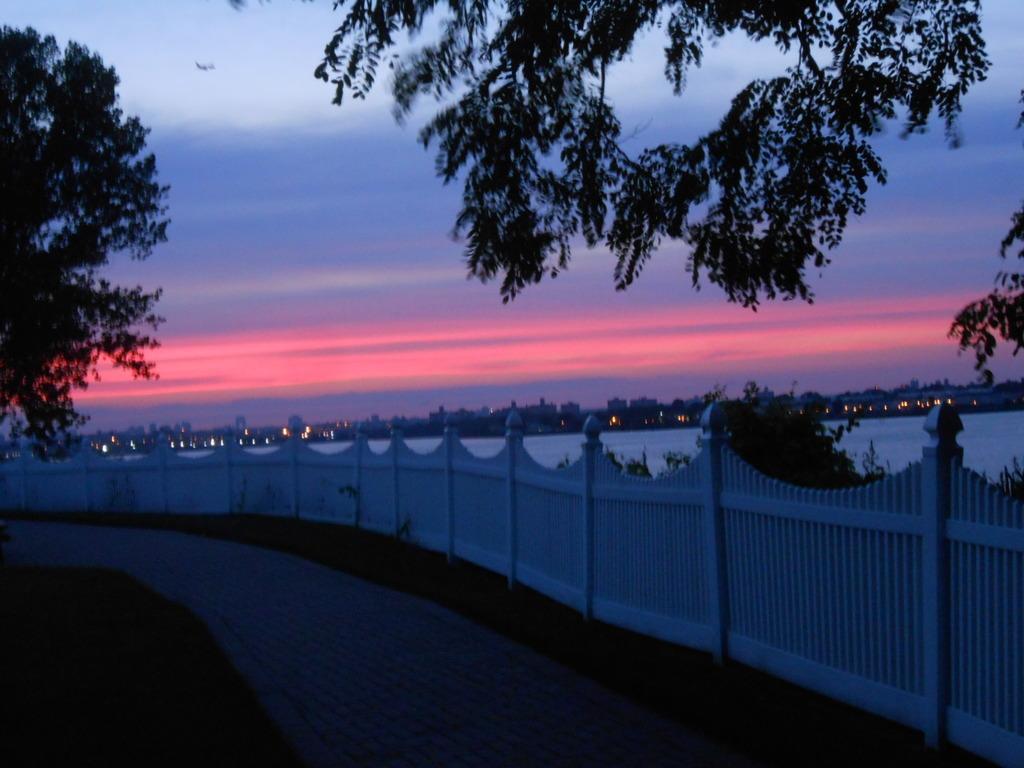Describe this image in one or two sentences. In this image at the bottom there is a walkway, grass and in the center there is fence and also we could see some trees. In the background there is a river, buildings, trees and lights. At the top there is sky. 